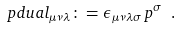<formula> <loc_0><loc_0><loc_500><loc_500>\ p d u a l _ { \mu \nu \lambda } \colon = \epsilon _ { \mu \nu \lambda \sigma } \, p ^ { \sigma } \ .</formula> 